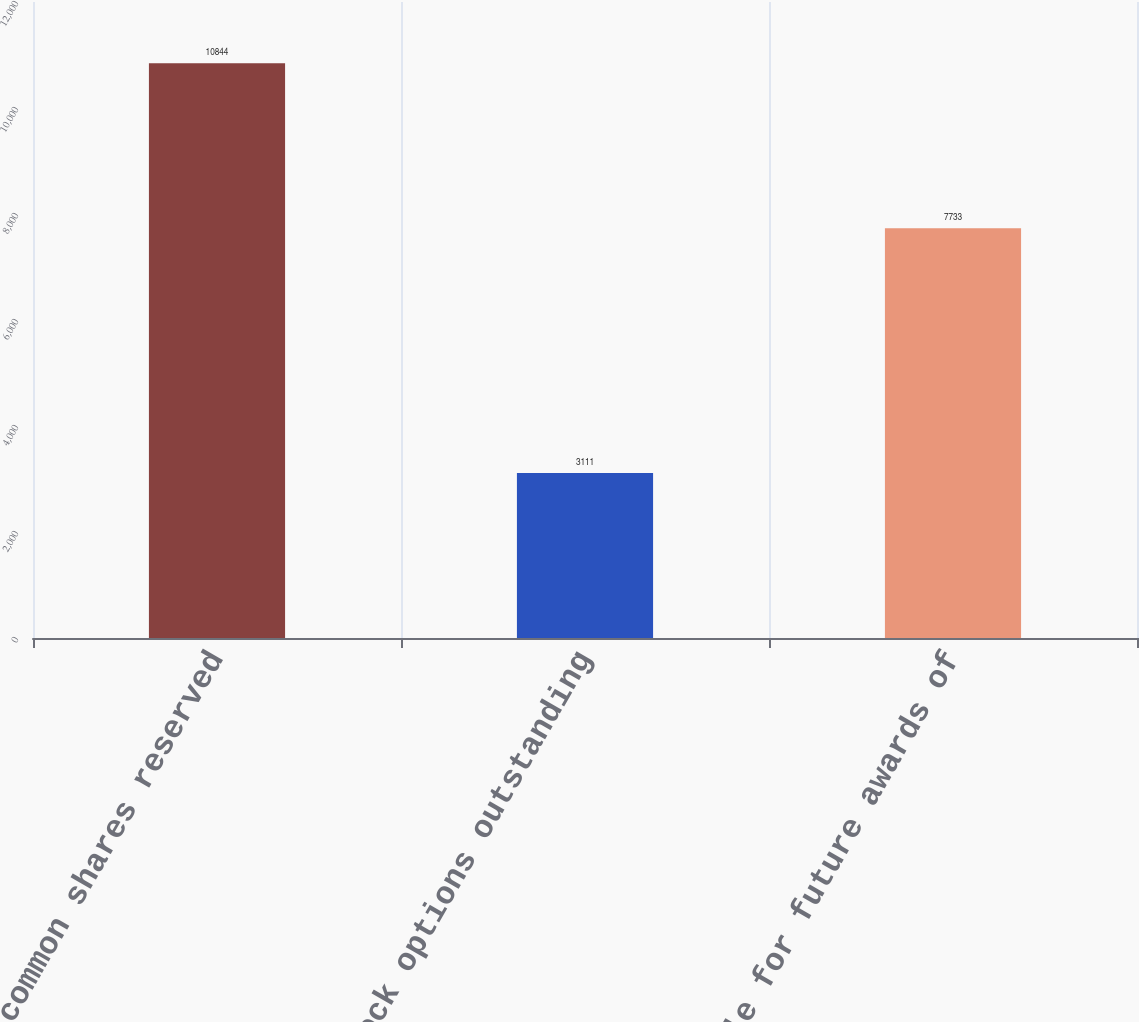Convert chart. <chart><loc_0><loc_0><loc_500><loc_500><bar_chart><fcel>Total common shares reserved<fcel>Less stock options outstanding<fcel>Available for future awards of<nl><fcel>10844<fcel>3111<fcel>7733<nl></chart> 